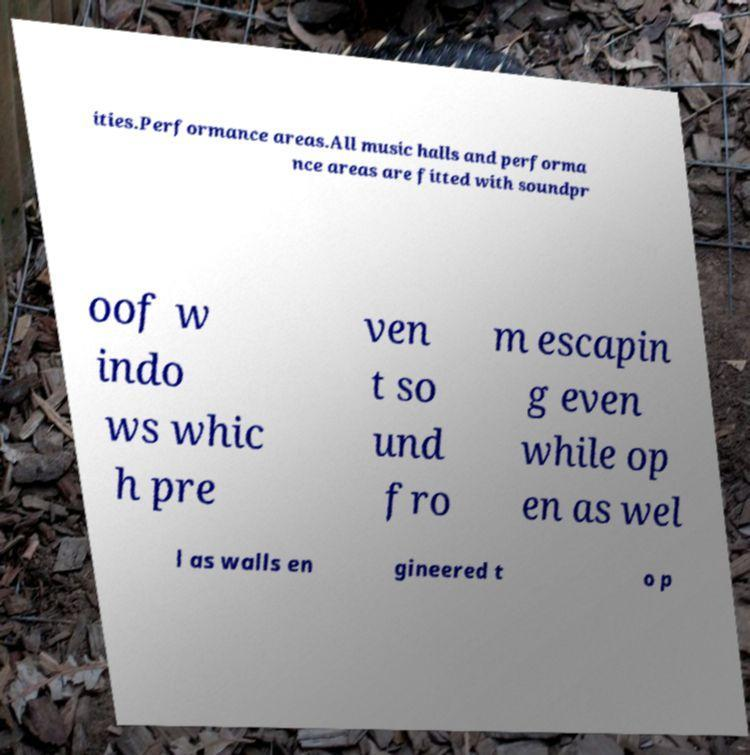For documentation purposes, I need the text within this image transcribed. Could you provide that? ities.Performance areas.All music halls and performa nce areas are fitted with soundpr oof w indo ws whic h pre ven t so und fro m escapin g even while op en as wel l as walls en gineered t o p 